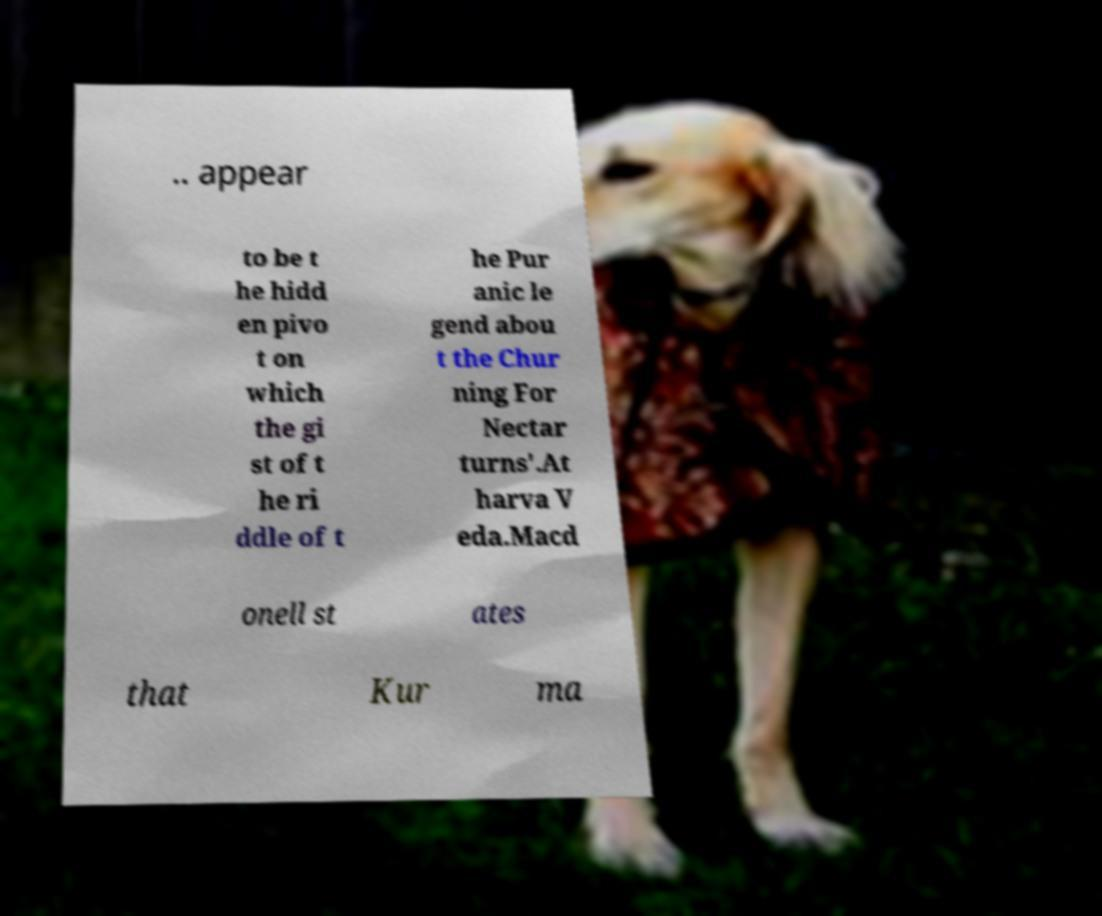Please read and relay the text visible in this image. What does it say? .. appear to be t he hidd en pivo t on which the gi st of t he ri ddle of t he Pur anic le gend abou t the Chur ning For Nectar turns'.At harva V eda.Macd onell st ates that Kur ma 